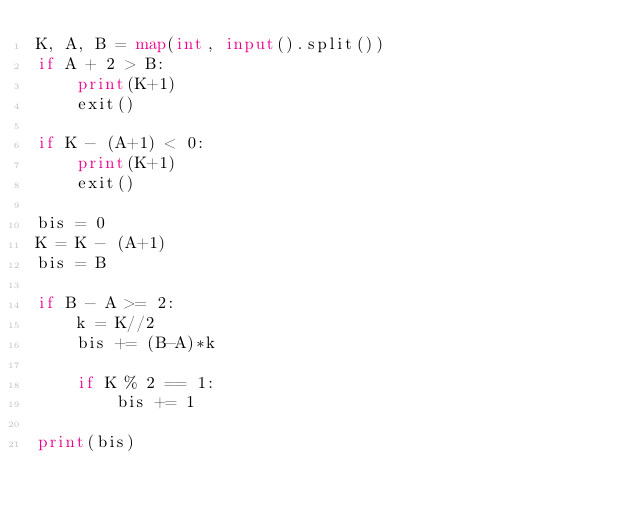Convert code to text. <code><loc_0><loc_0><loc_500><loc_500><_Python_>K, A, B = map(int, input().split())
if A + 2 > B:
    print(K+1)
    exit()

if K - (A+1) < 0:
    print(K+1)
    exit()

bis = 0
K = K - (A+1)
bis = B

if B - A >= 2:
    k = K//2
    bis += (B-A)*k

    if K % 2 == 1:
        bis += 1

print(bis)</code> 